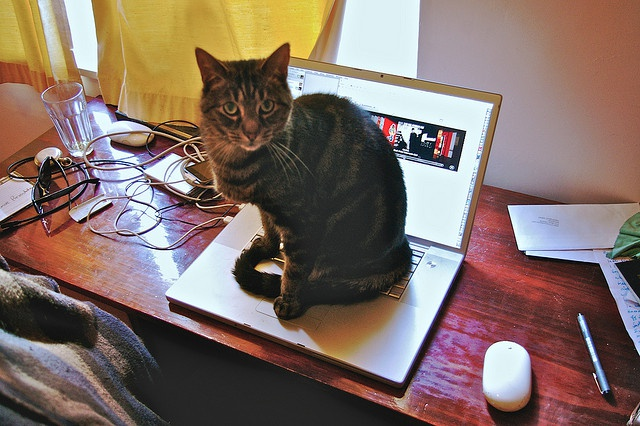Describe the objects in this image and their specific colors. I can see cat in tan, black, maroon, and brown tones, laptop in tan, white, black, darkgray, and gray tones, mouse in tan, white, darkgray, and lavender tones, and cup in tan, brown, darkgray, and lightblue tones in this image. 